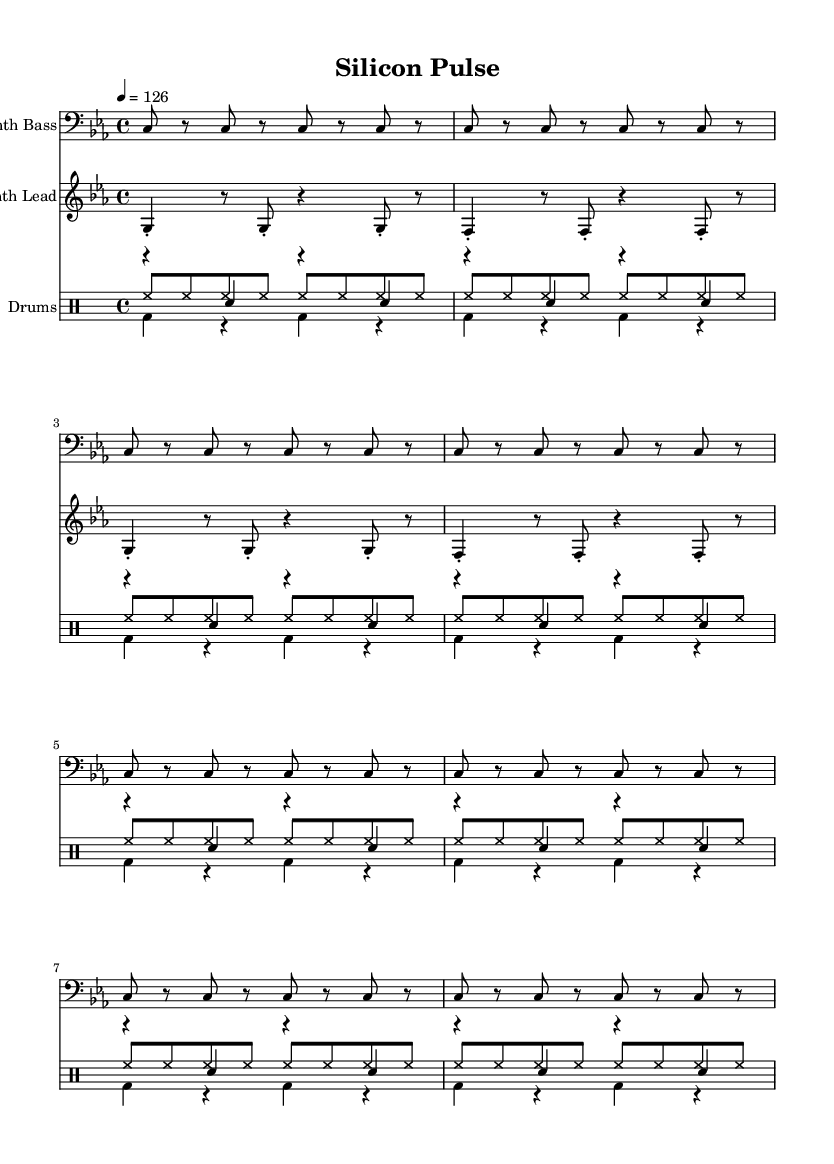What is the key signature of this music? The key signature is indicated at the beginning of the staff. The sheet music shows no sharps or flats, placing it in C minor.
Answer: C minor What is the time signature of this music? The time signature is found at the beginning of the piece and shows the number of beats per measure and the note value of each beat. Here, it is 4 over 4, meaning there are four beats in each measure and a quarter note receives one beat.
Answer: 4/4 What is the tempo marking of this piece? The tempo marking is located in the header section of the score, expressed as beats per minute. It indicates a speed of 126 beats per minute, which sets the pace for the music.
Answer: 126 How many measures does the synth bass part repeat? By analyzing the synth bass notation, it is indicated that the bass line repeats for 8 measures, as shown by the "repeat unfold" directive before the notes.
Answer: 8 What type of drum is predominantly used in this piece? Looking at the drum part, the notation includes hi-hat, kick drum, and snare drum. The hi-hat is the most frequent, being played in every eighth note throughout the repeating pattern of 8 measures.
Answer: Hi-hat What rhythmic pattern is established by the kick drum? The kick drum pattern is shown as it alternates with rests. Upon examining the notation, the kick drum plays on beats one and three and is silent on beats two and four, creating a simple repetitive rhythmic structure.
Answer: Kick on beats one and three Which instrument plays the lead melody in this piece? By observing the staffs in the score, the second staff labeled "Synth Lead" shows that this instrument plays the lead melody. This part consists of higher pitch notes, setting it apart from the bass and drum parts.
Answer: Synth Lead 